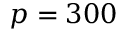<formula> <loc_0><loc_0><loc_500><loc_500>p = 3 0 0</formula> 